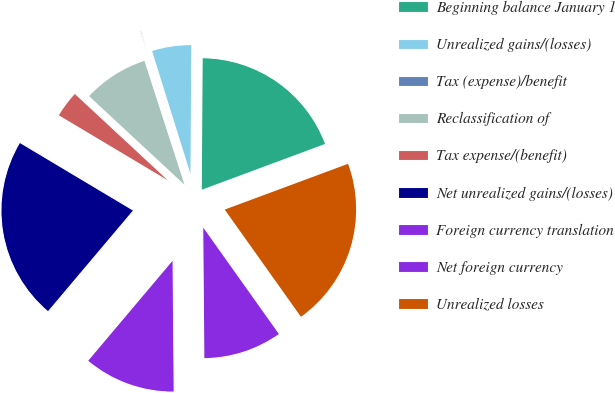Convert chart. <chart><loc_0><loc_0><loc_500><loc_500><pie_chart><fcel>Beginning balance January 1<fcel>Unrealized gains/(losses)<fcel>Tax (expense)/benefit<fcel>Reclassification of<fcel>Tax expense/(benefit)<fcel>Net unrealized gains/(losses)<fcel>Foreign currency translation<fcel>Net foreign currency<fcel>Unrealized losses<nl><fcel>19.23%<fcel>4.93%<fcel>0.16%<fcel>8.11%<fcel>3.34%<fcel>22.41%<fcel>11.29%<fcel>9.7%<fcel>20.82%<nl></chart> 